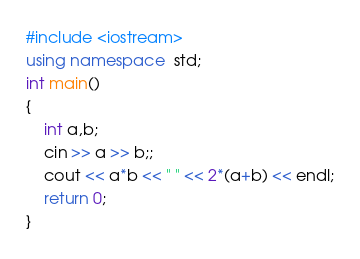Convert code to text. <code><loc_0><loc_0><loc_500><loc_500><_C++_>#include <iostream>
using namespace  std;
int main()
{
    int a,b;
    cin >> a >> b;;
    cout << a*b << " " << 2*(a+b) << endl;
    return 0;
}

</code> 